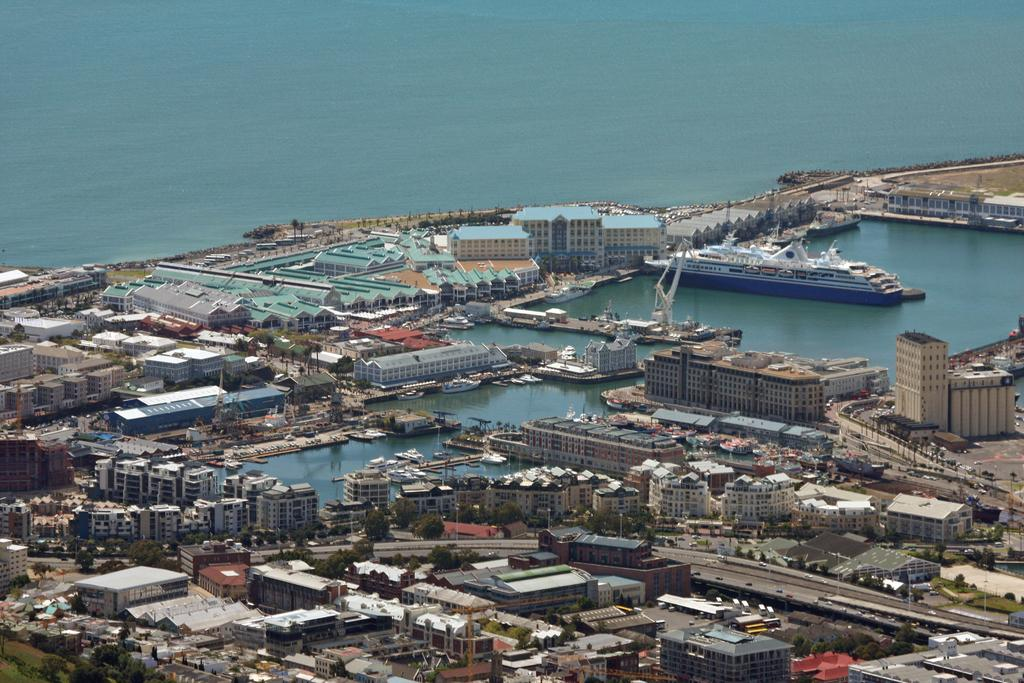What type of structures can be seen in the image? There are buildings in the image. What other natural elements are present in the image? There are trees and water visible in the image. What is on the water in the image? There are boats and a ship on the water. How does the road appear in the image? There is no road present in the image; it features buildings, trees, water, boats, and a ship. 